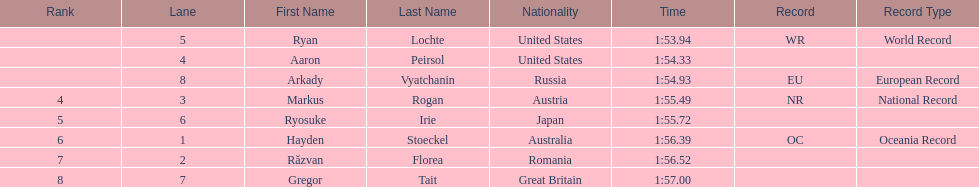Which competitor was the last to place? Gregor Tait. 